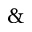<formula> <loc_0><loc_0><loc_500><loc_500>\&</formula> 